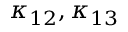Convert formula to latex. <formula><loc_0><loc_0><loc_500><loc_500>\kappa _ { 1 2 } , \kappa _ { 1 3 }</formula> 